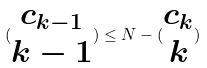Convert formula to latex. <formula><loc_0><loc_0><loc_500><loc_500>( \begin{matrix} c _ { k - 1 } \\ k - 1 \end{matrix} ) \leq N - ( \begin{matrix} c _ { k } \\ k \end{matrix} )</formula> 